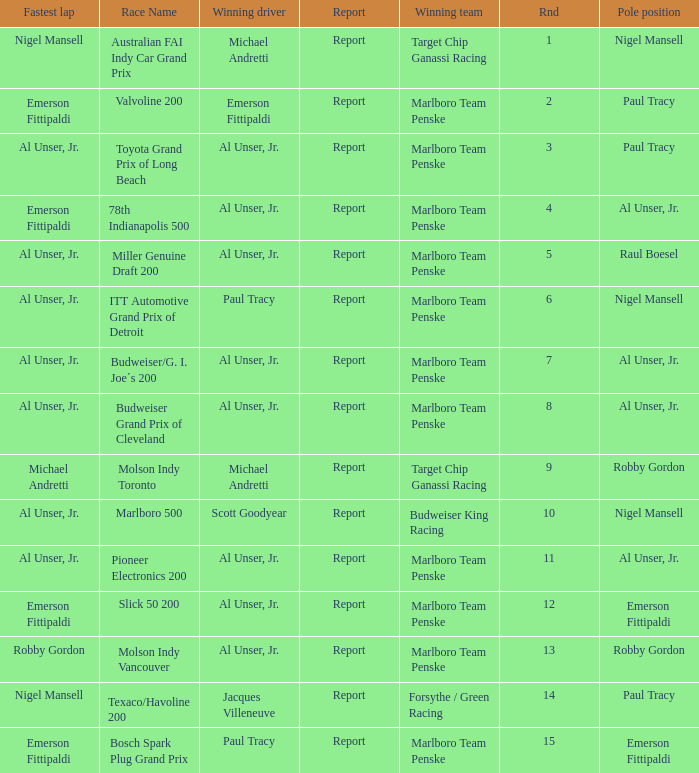Who did the fastest lap in the race won by Paul Tracy, with Emerson Fittipaldi at the pole position? Emerson Fittipaldi. 